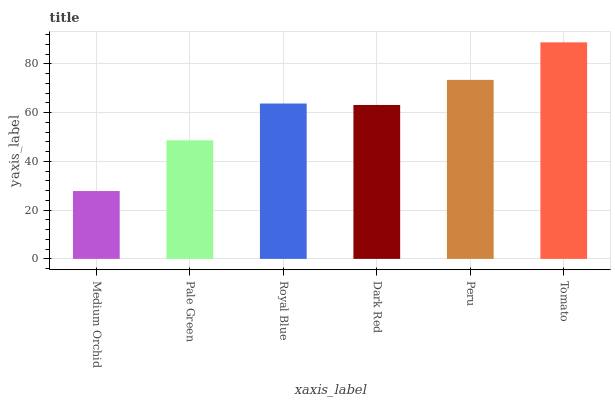Is Pale Green the minimum?
Answer yes or no. No. Is Pale Green the maximum?
Answer yes or no. No. Is Pale Green greater than Medium Orchid?
Answer yes or no. Yes. Is Medium Orchid less than Pale Green?
Answer yes or no. Yes. Is Medium Orchid greater than Pale Green?
Answer yes or no. No. Is Pale Green less than Medium Orchid?
Answer yes or no. No. Is Royal Blue the high median?
Answer yes or no. Yes. Is Dark Red the low median?
Answer yes or no. Yes. Is Pale Green the high median?
Answer yes or no. No. Is Pale Green the low median?
Answer yes or no. No. 